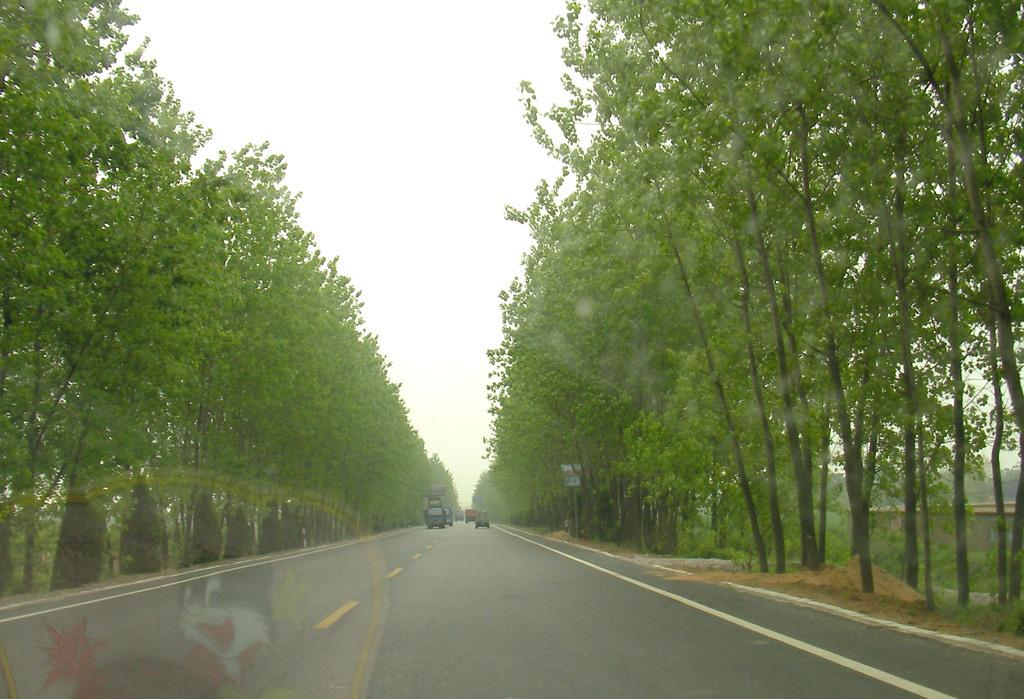What is the main feature of the image? There is a road in the image. What can be seen beside the road? There are trees beside the road. What is visible above the road and trees? The sky is visible in the image. What is moving along the road? There are vehicles on the road. What type of profit can be seen growing on the trees in the image? There is no mention of profit or any type of growth on the trees in the image; the trees are simply trees beside the road. 